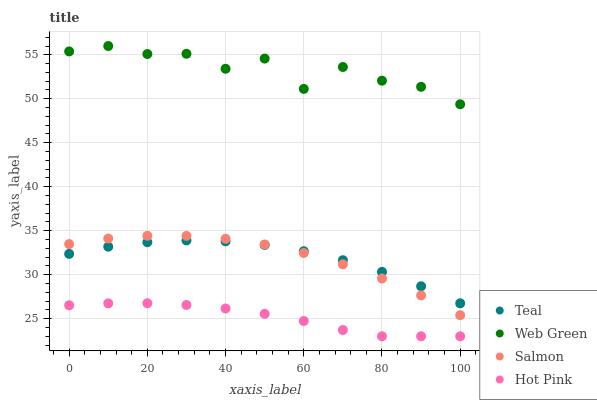Does Hot Pink have the minimum area under the curve?
Answer yes or no. Yes. Does Web Green have the maximum area under the curve?
Answer yes or no. Yes. Does Salmon have the minimum area under the curve?
Answer yes or no. No. Does Salmon have the maximum area under the curve?
Answer yes or no. No. Is Hot Pink the smoothest?
Answer yes or no. Yes. Is Web Green the roughest?
Answer yes or no. Yes. Is Salmon the smoothest?
Answer yes or no. No. Is Salmon the roughest?
Answer yes or no. No. Does Hot Pink have the lowest value?
Answer yes or no. Yes. Does Salmon have the lowest value?
Answer yes or no. No. Does Web Green have the highest value?
Answer yes or no. Yes. Does Salmon have the highest value?
Answer yes or no. No. Is Teal less than Web Green?
Answer yes or no. Yes. Is Web Green greater than Teal?
Answer yes or no. Yes. Does Teal intersect Salmon?
Answer yes or no. Yes. Is Teal less than Salmon?
Answer yes or no. No. Is Teal greater than Salmon?
Answer yes or no. No. Does Teal intersect Web Green?
Answer yes or no. No. 